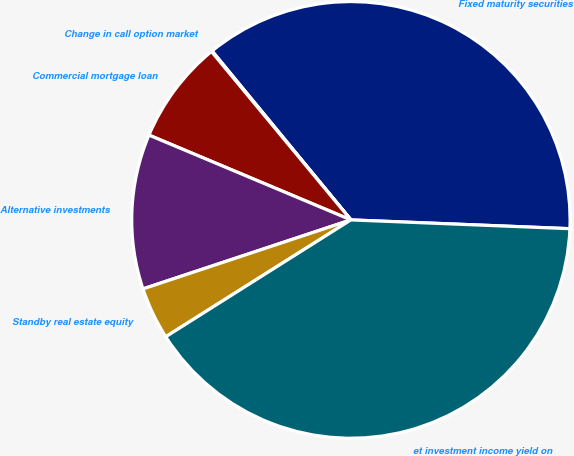Convert chart to OTSL. <chart><loc_0><loc_0><loc_500><loc_500><pie_chart><fcel>Fixed maturity securities<fcel>Change in call option market<fcel>Commercial mortgage loan<fcel>Alternative investments<fcel>Standby real estate equity<fcel>et investment income yield on<nl><fcel>36.56%<fcel>0.06%<fcel>7.67%<fcel>11.47%<fcel>3.87%<fcel>40.37%<nl></chart> 